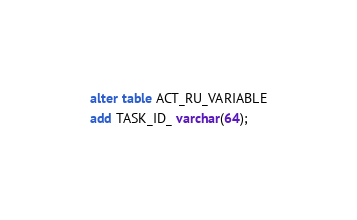<code> <loc_0><loc_0><loc_500><loc_500><_SQL_>alter table ACT_RU_VARIABLE
add TASK_ID_ varchar(64);
</code> 